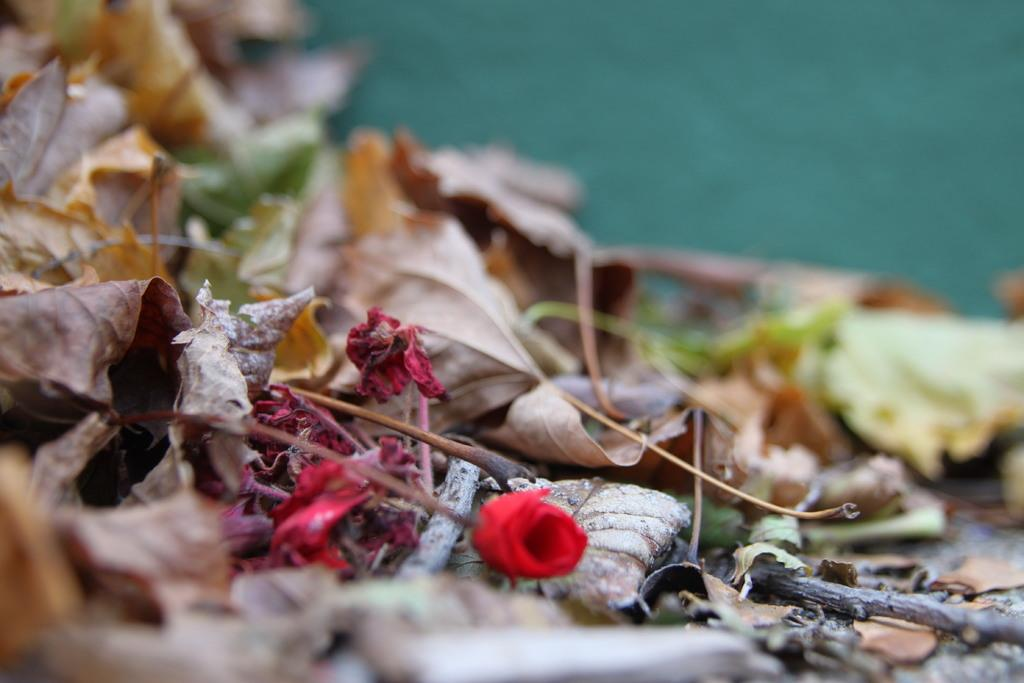What type of flower is present in the image? There is a red flower with a stem in the image. What other natural elements can be seen in the image? There are dry leaves and sticks in the image. How would you describe the background of the image? The background has a blurred view. How many ladybugs can be seen crawling on the red flower in the image? There are no ladybugs present in the image; it only features a red flower, dry leaves, and sticks. What type of behavior can be observed in the snakes in the image? There are no snakes present in the image, so their behavior cannot be observed. 